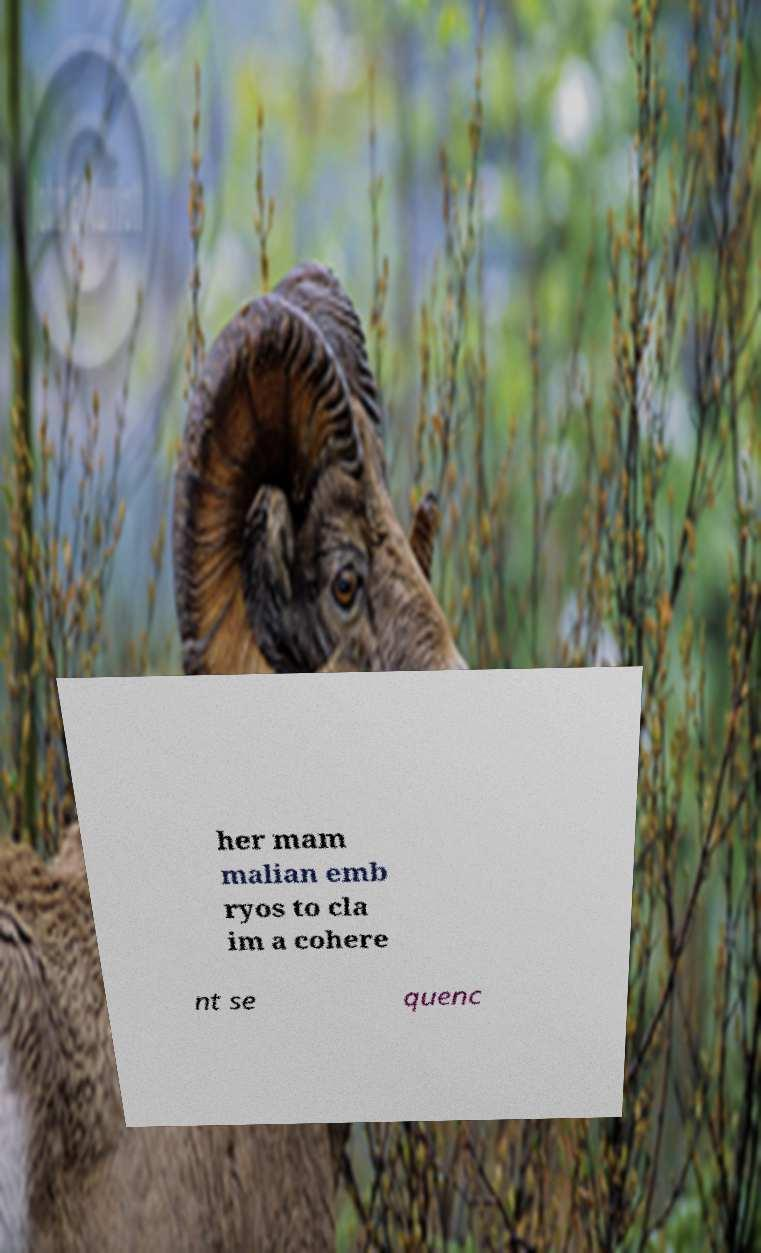Please identify and transcribe the text found in this image. her mam malian emb ryos to cla im a cohere nt se quenc 